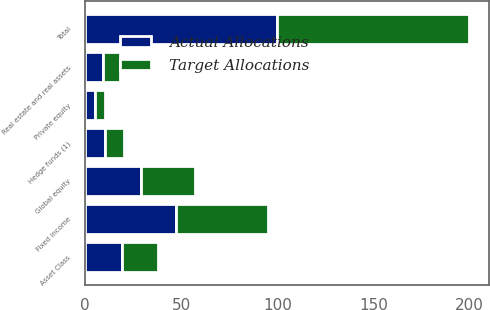<chart> <loc_0><loc_0><loc_500><loc_500><stacked_bar_chart><ecel><fcel>Asset Class<fcel>Fixed income<fcel>Global equity<fcel>Private equity<fcel>Real estate and real assets<fcel>Hedge funds (1)<fcel>Total<nl><fcel>Target Allocations<fcel>19<fcel>48<fcel>28<fcel>5<fcel>9<fcel>10<fcel>100<nl><fcel>Actual Allocations<fcel>19<fcel>47<fcel>29<fcel>5<fcel>9<fcel>10<fcel>100<nl></chart> 